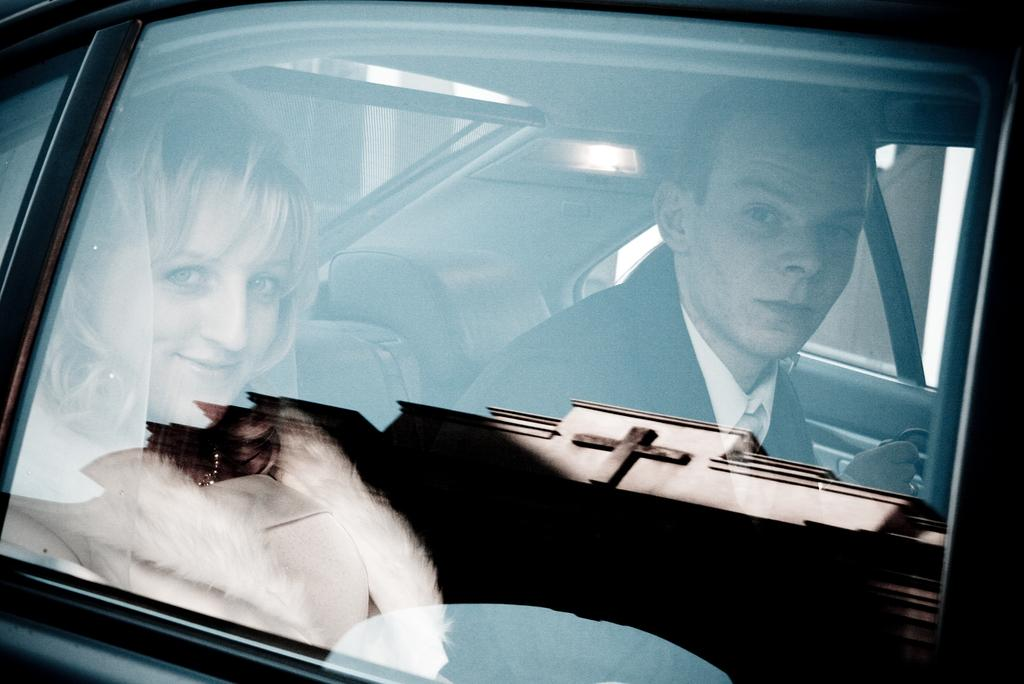What is happening in the image involving people? There are people in a vehicle in the image. What can be seen inside the vehicle? Car seats are visible in the image. What material is present in the image that allows for visibility? Glass is present in the image. What effect can be observed on the glass in the image? There are reflections on the glass in the image. What type of curtain can be seen hanging in the vehicle in the image? There is no curtain present in the vehicle in the image. What is the weight of the soda being consumed by the people in the image? There is no soda being consumed by the people in the image, so it cannot be determined. 